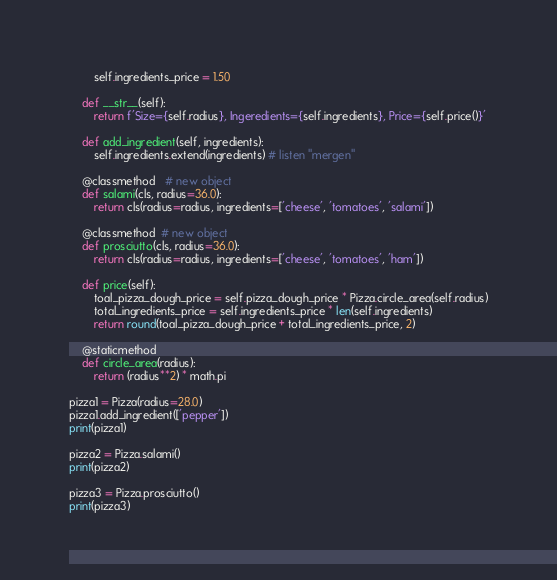<code> <loc_0><loc_0><loc_500><loc_500><_Python_>        self.ingredients_price = 1.50

    def __str__(self):
        return f'Size={self.radius}, Ingeredients={self.ingredients}, Price={self.price()}'

    def add_ingredient(self, ingredients):
        self.ingredients.extend(ingredients) # listen "mergen"

    @classmethod   # new object
    def salami(cls, radius=36.0):
        return cls(radius=radius, ingredients=['cheese', 'tomatoes', 'salami'])

    @classmethod  # new object
    def prosciutto(cls, radius=36.0):
        return cls(radius=radius, ingredients=['cheese', 'tomatoes', 'ham'])

    def price(self):
        toal_pizza_dough_price = self.pizza_dough_price * Pizza.circle_area(self.radius)
        total_ingredients_price = self.ingredients_price * len(self.ingredients)
        return round(toal_pizza_dough_price + total_ingredients_price, 2)

    @staticmethod
    def circle_area(radius):
        return (radius**2) * math.pi

pizza1 = Pizza(radius=28.0)
pizza1.add_ingredient(['pepper'])
print(pizza1)

pizza2 = Pizza.salami()
print(pizza2)

pizza3 = Pizza.prosciutto()
print(pizza3)


</code> 